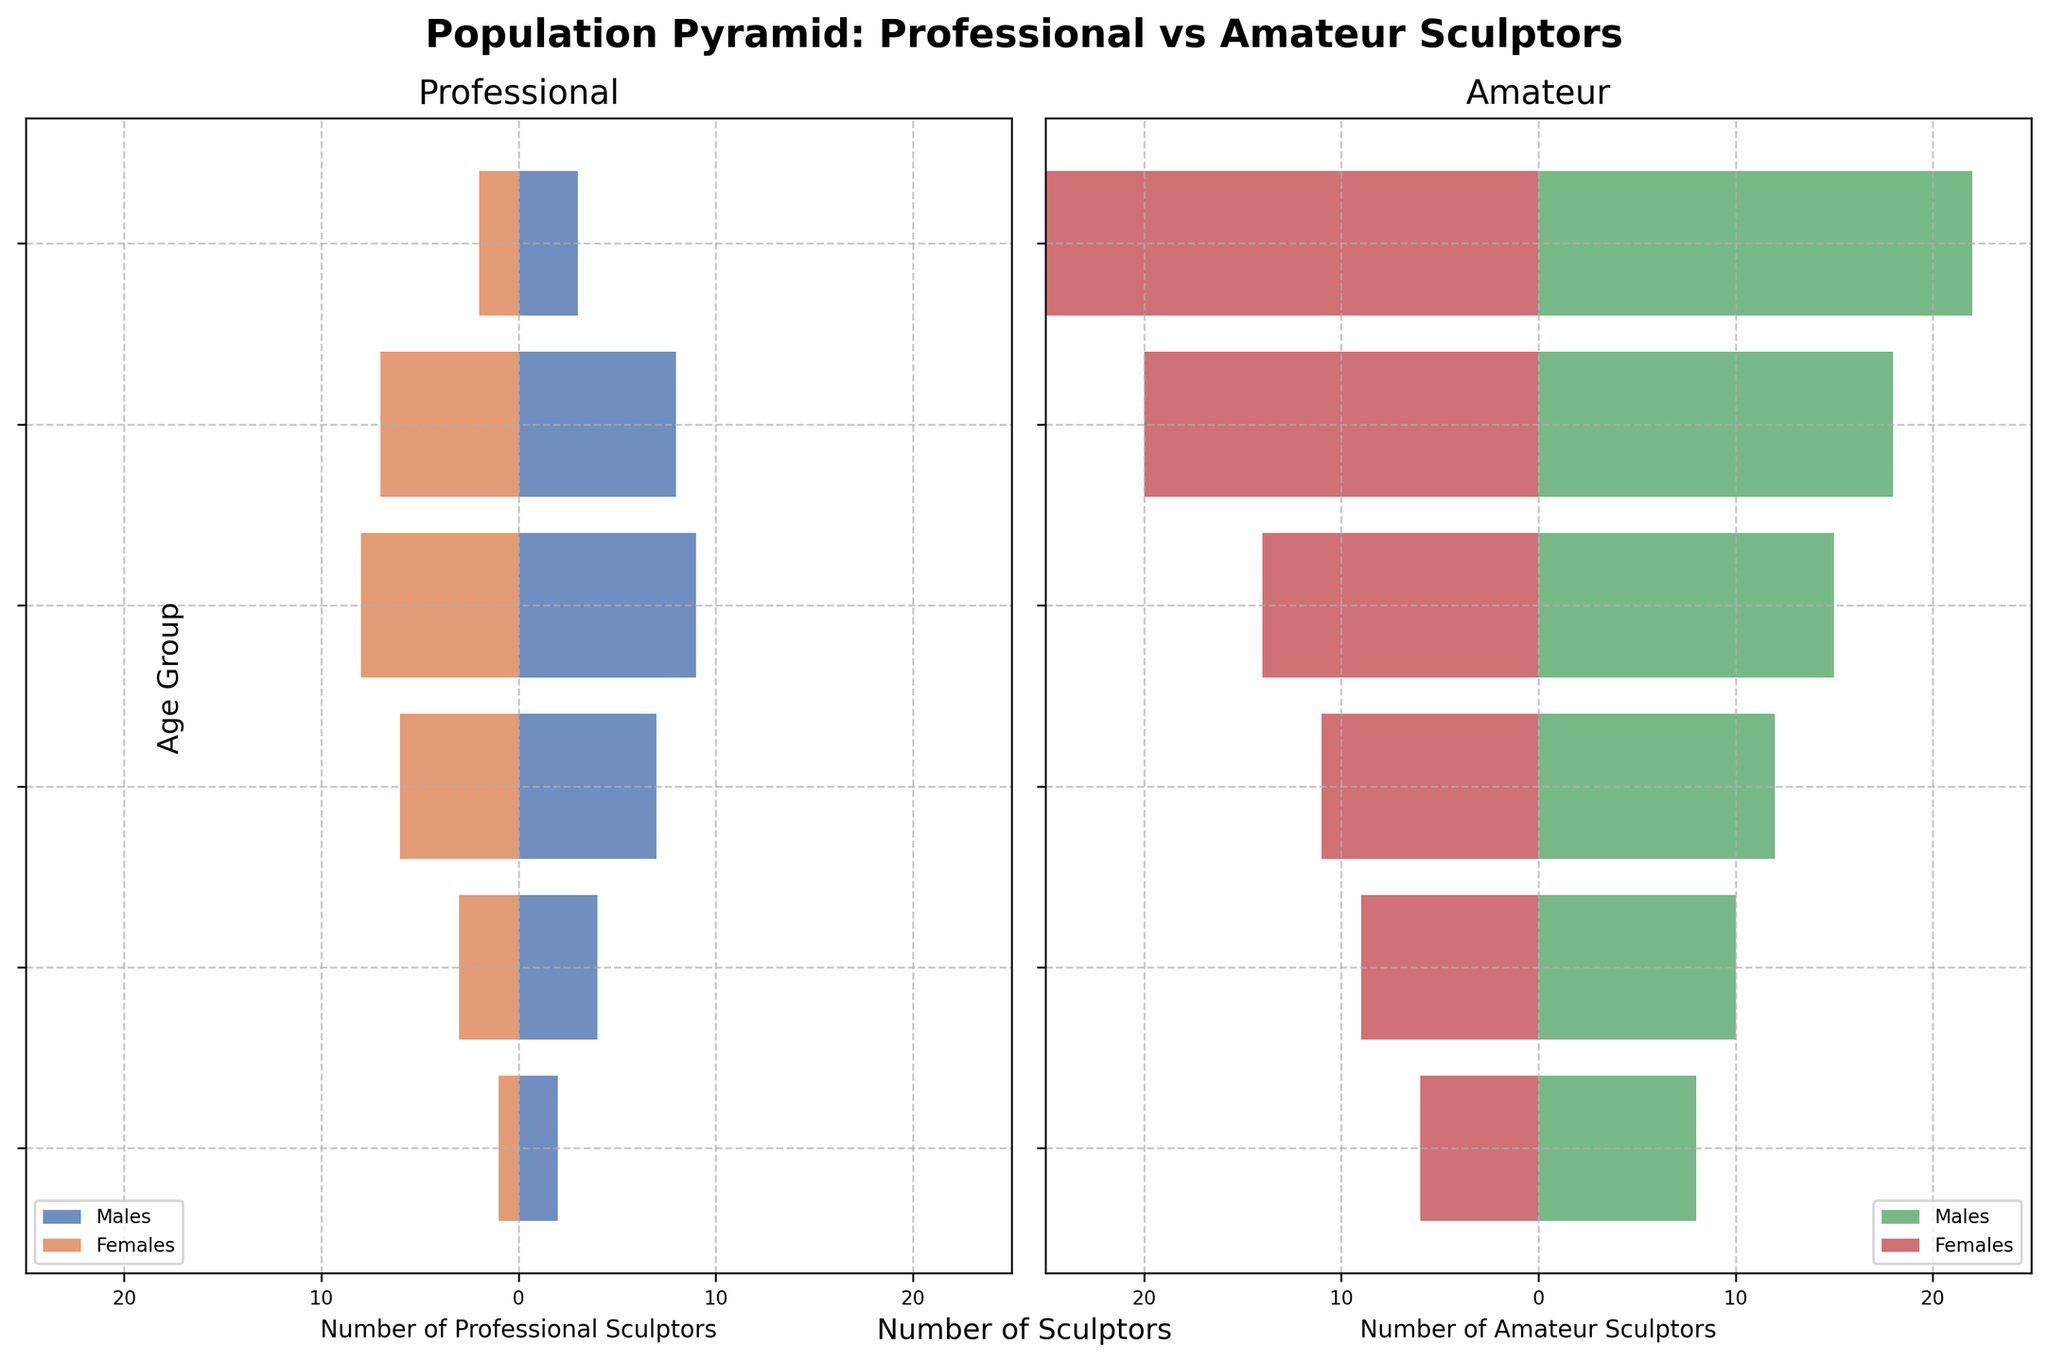What's the title of the figure? The title of the figure is written at the top of the plot. The title is 'Population Pyramid: Professional vs Amateur Sculptors'
Answer: Population Pyramid: Professional vs Amateur Sculptors Which age group has the highest number of professional male sculptors? By looking at the horizontal bar lengths in the Professional section, the age group 35-44 has the highest number of professional male sculptors with a value of 9.
Answer: 35-44 How many professional female sculptors are in the age group 45-54? In the Professional section, the bar length for females in the age group 45-54 corresponds to 6.
Answer: 6 What's the total number of sculptors in the age group 55-64 across both males and females for amateurs? In the Amateur section, the bars for the age group 55-64 show 10 males and 9 females. The total is 10 + 9 = 19.
Answer: 19 How does the number of amateur female sculptors aged 18-24 compare to professional female sculptors in the same age group? In the Amateur section, the bar for females aged 18-24 shows 25, while in the Professional section, the bar is at 2. Therefore, there are 23 more amateur female sculptors than professional female sculptors in this age group.
Answer: 23 more Is the number of male amateur sculptors aged 25-34 greater than the number of professional male sculptors in the same age group? In the 25-34 age group, the Amateur section shows 18 males, and the Professional section shows 8 males. 18 is greater than 8, so yes.
Answer: Yes Which group has more sculptors aged 35-44, amateurs or professionals? In the Professional section, the 35-44 age group has 9 males and 8 females (total 17). In the Amateur section, there are 15 males and 14 females (total 29). Amateurs have more sculptors in this age group.
Answer: Amateurs What's the difference in the number of professional and amateur male sculptors aged 65+? In the 65+ age group, there are 2 professional males and 8 amateur males. The difference is 8 - 2 = 6.
Answer: 6 Compare the total number of sculptors in the age group 45-54 across amateurs and professionals. Professionals have 7 males and 6 females (total 13), while amateurs have 12 males and 11 females (total 23). Thus, amateurs have 23 - 13 = 10 more sculptors.
Answer: 10 more amateurs Which has more sculptors aged 18-24, amateur males or amateur females? In the 18-24 age group of the Amateur section, there are 22 males and 25 females. There are more females than males.
Answer: Amateur females 